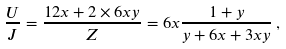<formula> <loc_0><loc_0><loc_500><loc_500>\frac { U } { J } = \frac { 1 2 x + 2 \times 6 x y } Z = 6 x \frac { 1 + y } { y + 6 x + 3 x y } \, ,</formula> 